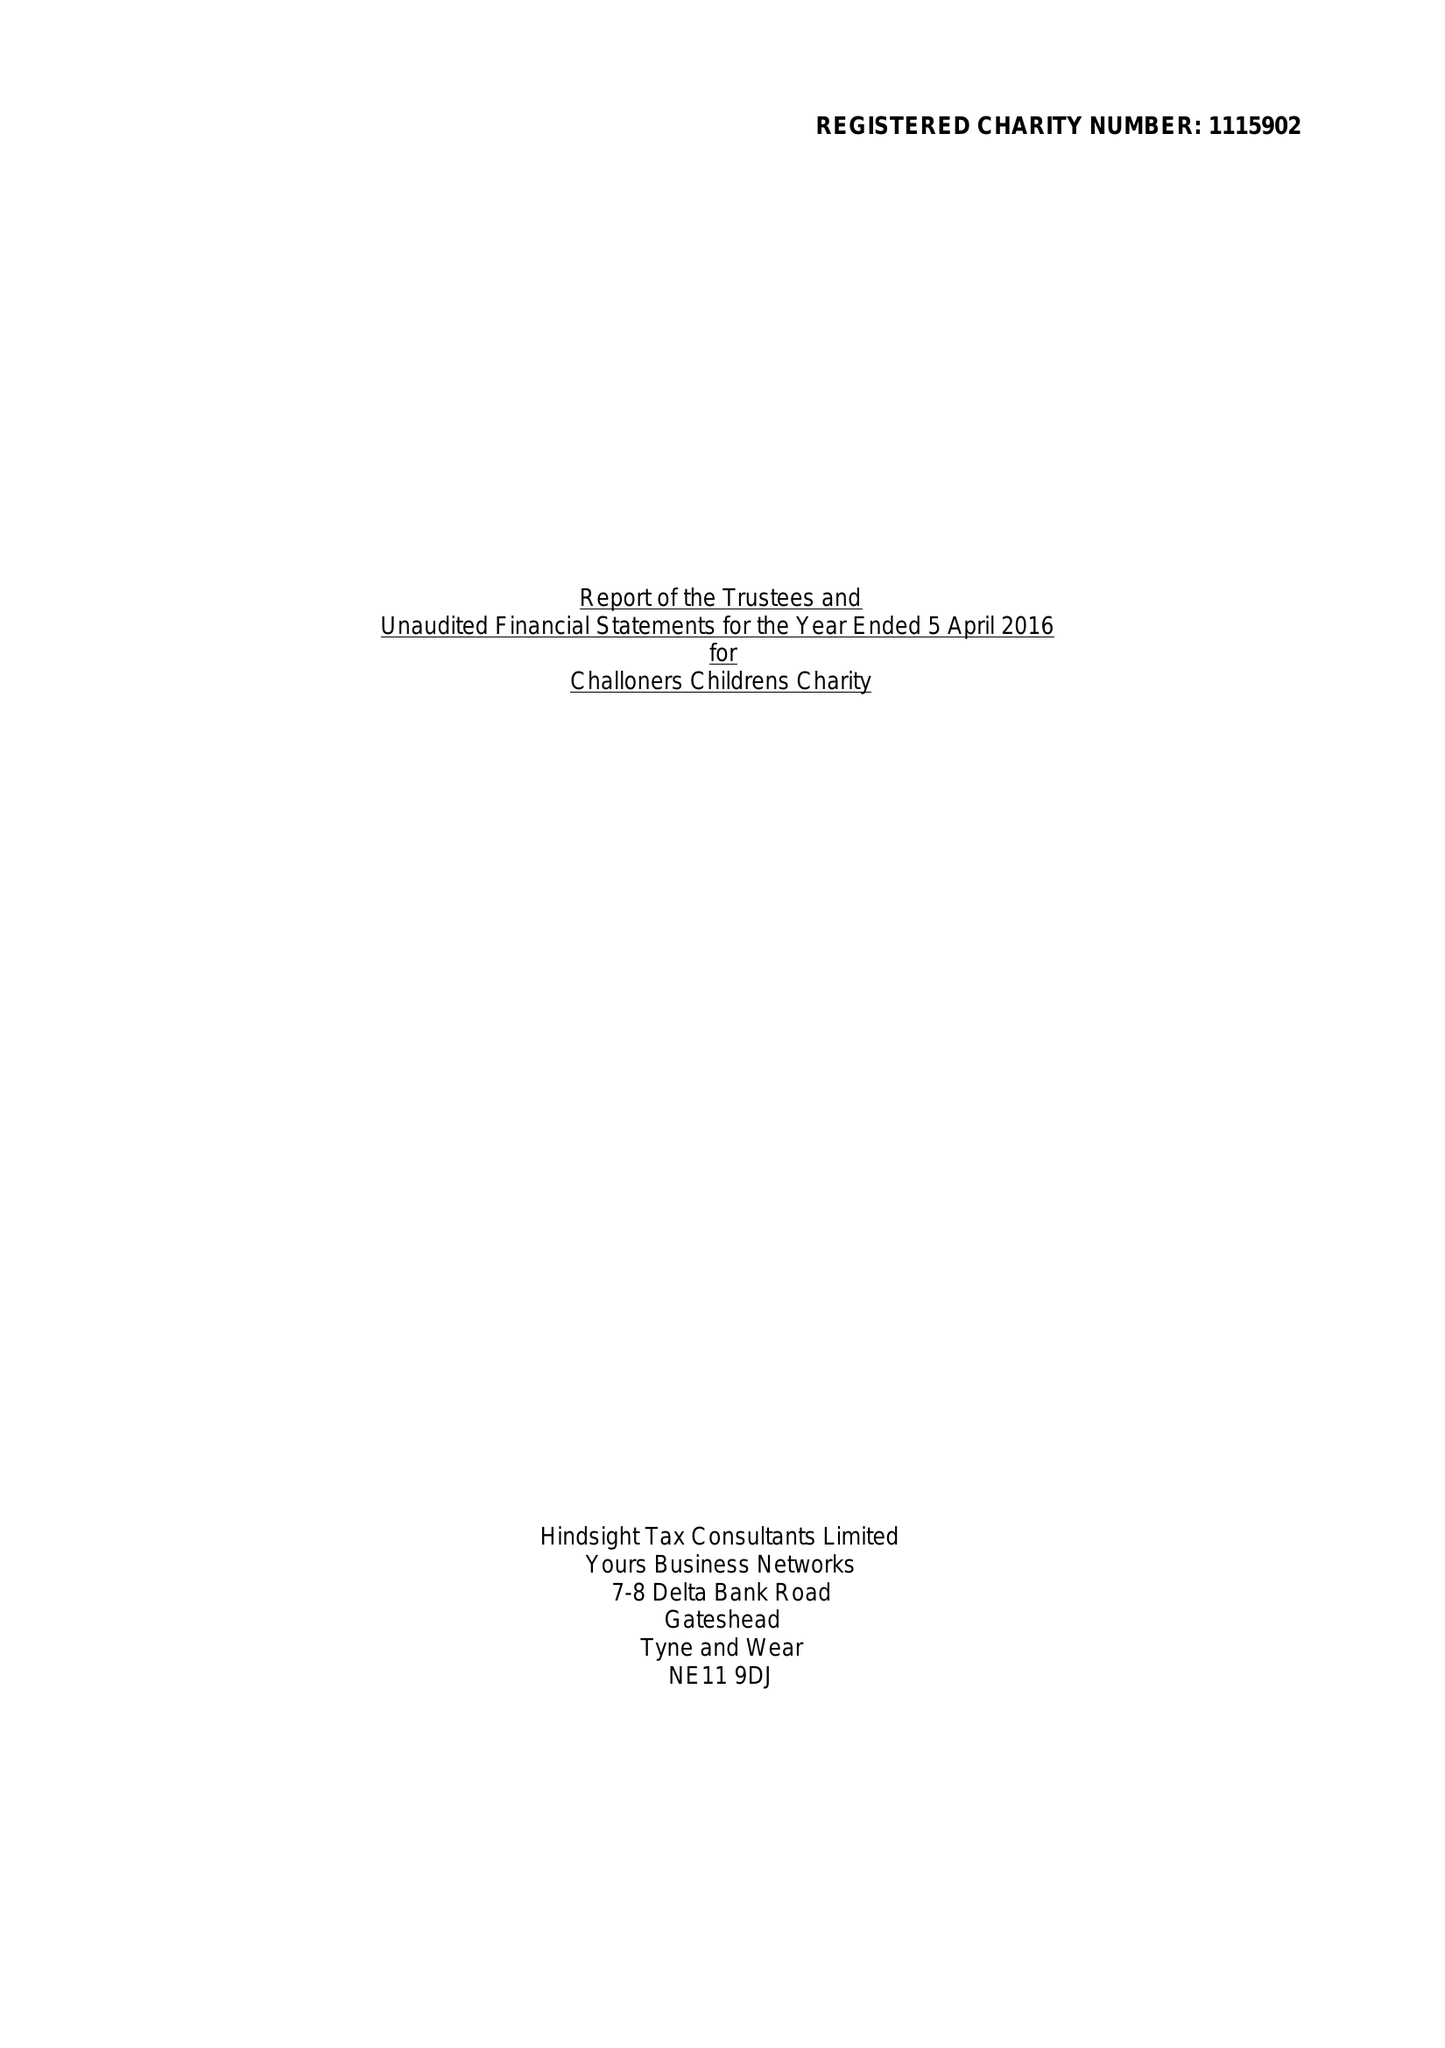What is the value for the charity_name?
Answer the question using a single word or phrase. Chaloner Childrens Charity 